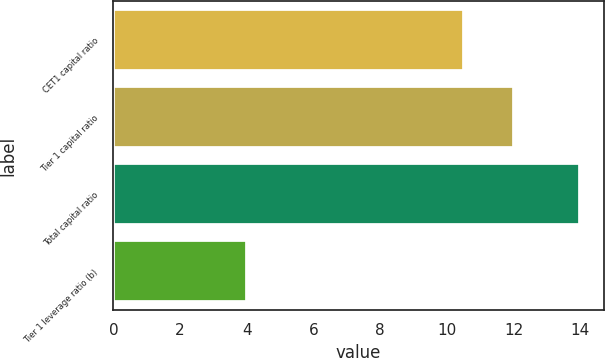Convert chart to OTSL. <chart><loc_0><loc_0><loc_500><loc_500><bar_chart><fcel>CET1 capital ratio<fcel>Tier 1 capital ratio<fcel>Total capital ratio<fcel>Tier 1 leverage ratio (b)<nl><fcel>10.5<fcel>12<fcel>14<fcel>4<nl></chart> 